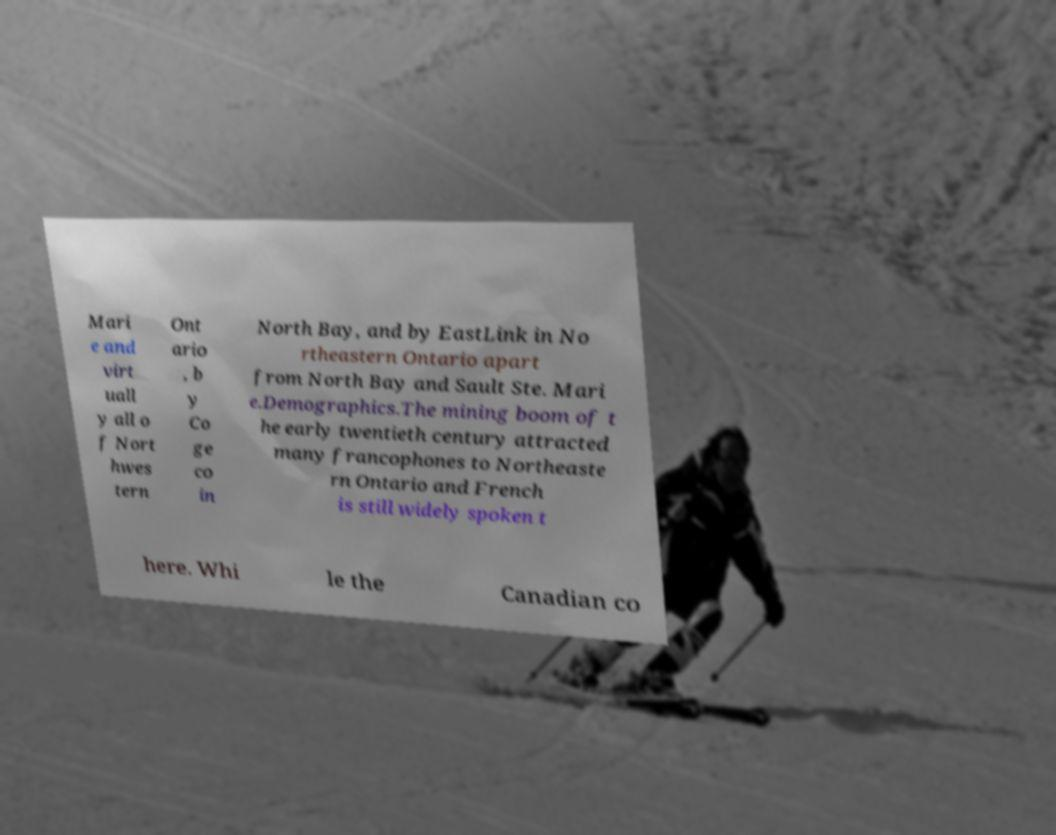Could you extract and type out the text from this image? Mari e and virt uall y all o f Nort hwes tern Ont ario , b y Co ge co in North Bay, and by EastLink in No rtheastern Ontario apart from North Bay and Sault Ste. Mari e.Demographics.The mining boom of t he early twentieth century attracted many francophones to Northeaste rn Ontario and French is still widely spoken t here. Whi le the Canadian co 